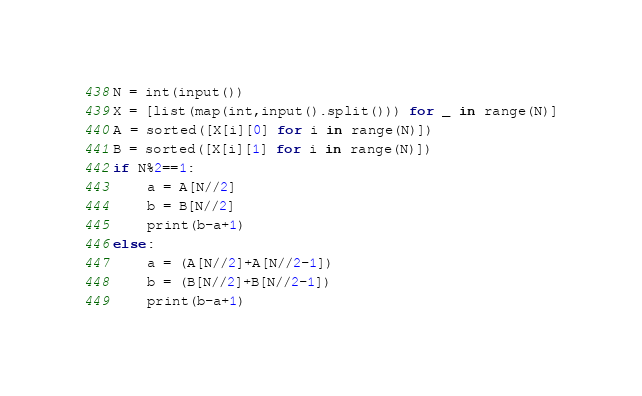Convert code to text. <code><loc_0><loc_0><loc_500><loc_500><_Python_>N = int(input())
X = [list(map(int,input().split())) for _ in range(N)]
A = sorted([X[i][0] for i in range(N)])
B = sorted([X[i][1] for i in range(N)])
if N%2==1:
    a = A[N//2]
    b = B[N//2]
    print(b-a+1)
else:
    a = (A[N//2]+A[N//2-1])
    b = (B[N//2]+B[N//2-1])
    print(b-a+1)</code> 